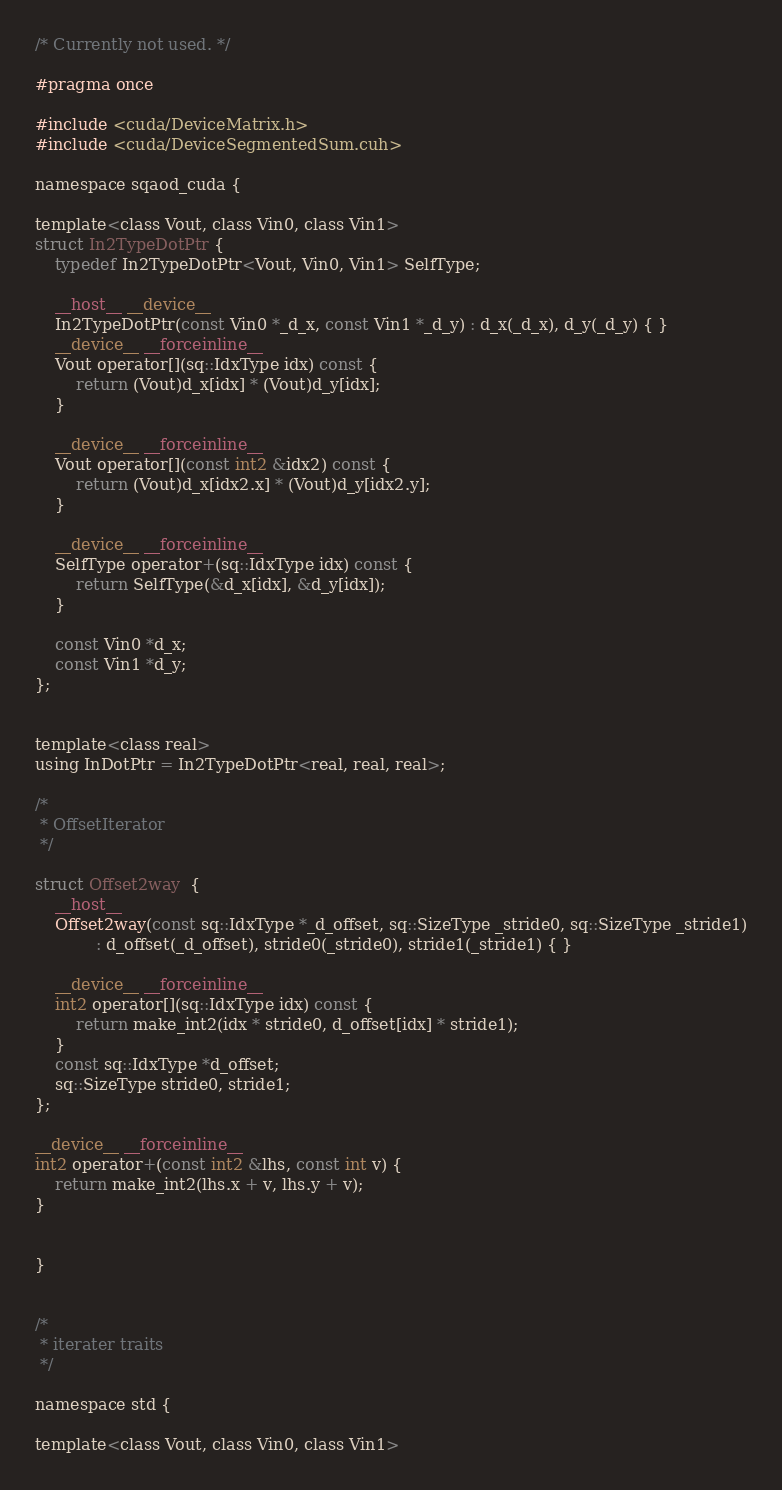<code> <loc_0><loc_0><loc_500><loc_500><_Cuda_>/* Currently not used. */

#pragma once

#include <cuda/DeviceMatrix.h>
#include <cuda/DeviceSegmentedSum.cuh>

namespace sqaod_cuda {

template<class Vout, class Vin0, class Vin1>
struct In2TypeDotPtr {
    typedef In2TypeDotPtr<Vout, Vin0, Vin1> SelfType;

    __host__ __device__
    In2TypeDotPtr(const Vin0 *_d_x, const Vin1 *_d_y) : d_x(_d_x), d_y(_d_y) { }
    __device__ __forceinline__
    Vout operator[](sq::IdxType idx) const {
        return (Vout)d_x[idx] * (Vout)d_y[idx];
    }

    __device__ __forceinline__
    Vout operator[](const int2 &idx2) const {
        return (Vout)d_x[idx2.x] * (Vout)d_y[idx2.y];
    }

    __device__ __forceinline__
    SelfType operator+(sq::IdxType idx) const {
        return SelfType(&d_x[idx], &d_y[idx]);
    }

    const Vin0 *d_x;
    const Vin1 *d_y;
};


template<class real>
using InDotPtr = In2TypeDotPtr<real, real, real>;

/*
 * OffsetIterator
 */

struct Offset2way  {
    __host__
    Offset2way(const sq::IdxType *_d_offset, sq::SizeType _stride0, sq::SizeType _stride1)
            : d_offset(_d_offset), stride0(_stride0), stride1(_stride1) { }

    __device__ __forceinline__
    int2 operator[](sq::IdxType idx) const {
        return make_int2(idx * stride0, d_offset[idx] * stride1);
    }
    const sq::IdxType *d_offset;
    sq::SizeType stride0, stride1;
};

__device__ __forceinline__
int2 operator+(const int2 &lhs, const int v) {
    return make_int2(lhs.x + v, lhs.y + v);
}


}


/*
 * iterater traits
 */

namespace std {

template<class Vout, class Vin0, class Vin1></code> 